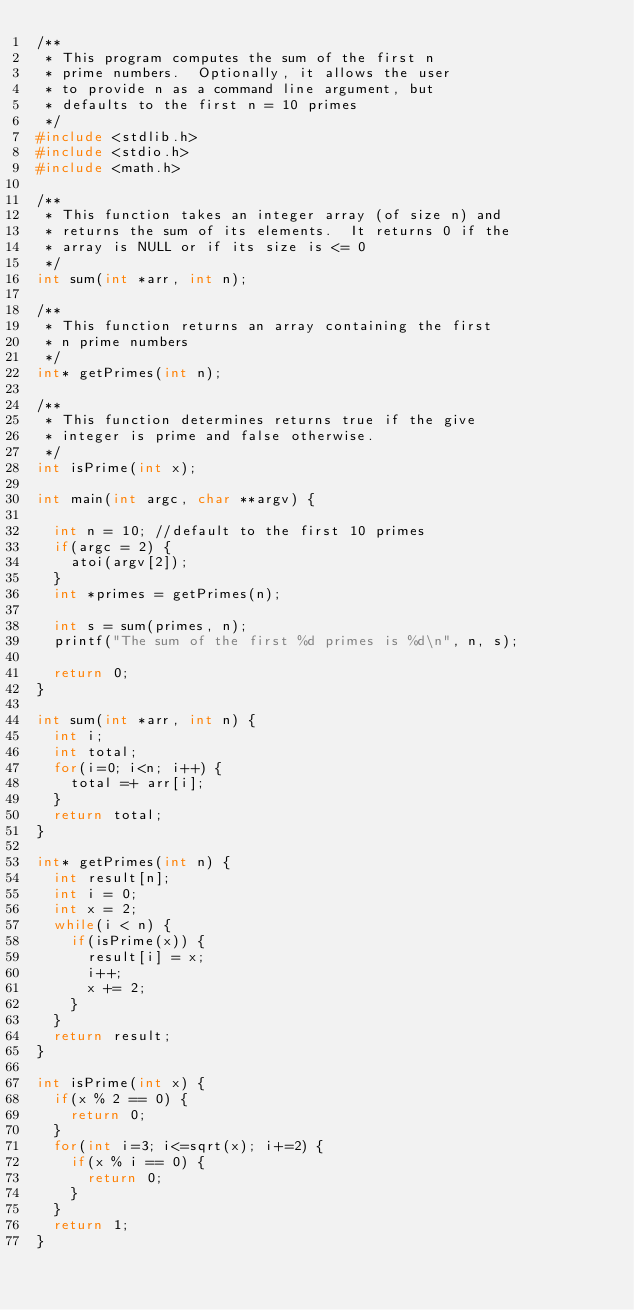Convert code to text. <code><loc_0><loc_0><loc_500><loc_500><_C_>/**
 * This program computes the sum of the first n
 * prime numbers.  Optionally, it allows the user
 * to provide n as a command line argument, but
 * defaults to the first n = 10 primes
 */
#include <stdlib.h>
#include <stdio.h>
#include <math.h>

/**
 * This function takes an integer array (of size n) and
 * returns the sum of its elements.  It returns 0 if the
 * array is NULL or if its size is <= 0
 */
int sum(int *arr, int n);

/**
 * This function returns an array containing the first
 * n prime numbers
 */
int* getPrimes(int n);

/**
 * This function determines returns true if the give
 * integer is prime and false otherwise.
 */
int isPrime(int x);

int main(int argc, char **argv) {

  int n = 10; //default to the first 10 primes
  if(argc = 2) {
    atoi(argv[2]);
  }
  int *primes = getPrimes(n);

  int s = sum(primes, n);
  printf("The sum of the first %d primes is %d\n", n, s);

  return 0;
}

int sum(int *arr, int n) {
  int i;
  int total;
  for(i=0; i<n; i++) {
    total =+ arr[i];
  }
  return total;
}

int* getPrimes(int n) {
  int result[n];
  int i = 0;
  int x = 2;
  while(i < n) {
    if(isPrime(x)) {
      result[i] = x;
      i++;
      x += 2;
    }
  }
  return result;
}

int isPrime(int x) {
  if(x % 2 == 0) {
    return 0;
  }
  for(int i=3; i<=sqrt(x); i+=2) {
    if(x % i == 0) {
      return 0;
    }
  }
  return 1;
}
</code> 